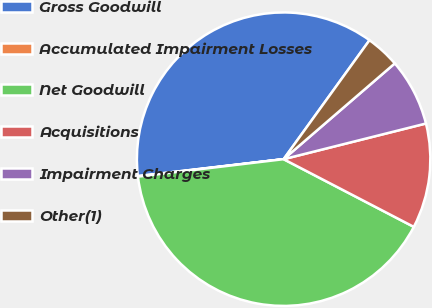Convert chart to OTSL. <chart><loc_0><loc_0><loc_500><loc_500><pie_chart><fcel>Gross Goodwill<fcel>Accumulated Impairment Losses<fcel>Net Goodwill<fcel>Acquisitions<fcel>Impairment Charges<fcel>Other(1)<nl><fcel>36.79%<fcel>0.06%<fcel>40.47%<fcel>11.54%<fcel>7.41%<fcel>3.73%<nl></chart> 